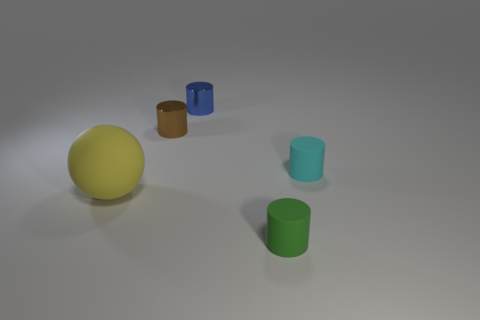There is a shiny cylinder that is the same size as the blue thing; what is its color?
Your response must be concise. Brown. There is a blue shiny cylinder; what number of metallic objects are to the left of it?
Keep it short and to the point. 1. Is there a big metal cube?
Provide a short and direct response. No. There is a thing behind the tiny object to the left of the metal cylinder behind the brown shiny object; how big is it?
Give a very brief answer. Small. How many other things are the same size as the yellow rubber thing?
Ensure brevity in your answer.  0. How big is the rubber object that is in front of the big yellow matte ball?
Provide a succinct answer. Small. Does the blue thing that is left of the cyan rubber object have the same material as the green thing?
Provide a succinct answer. No. How many tiny cylinders are both behind the small cyan matte object and in front of the yellow sphere?
Ensure brevity in your answer.  0. There is a matte thing that is to the left of the rubber cylinder that is in front of the cyan object; what is its size?
Provide a succinct answer. Large. Are there more small blue metallic things than metal things?
Provide a short and direct response. No. 